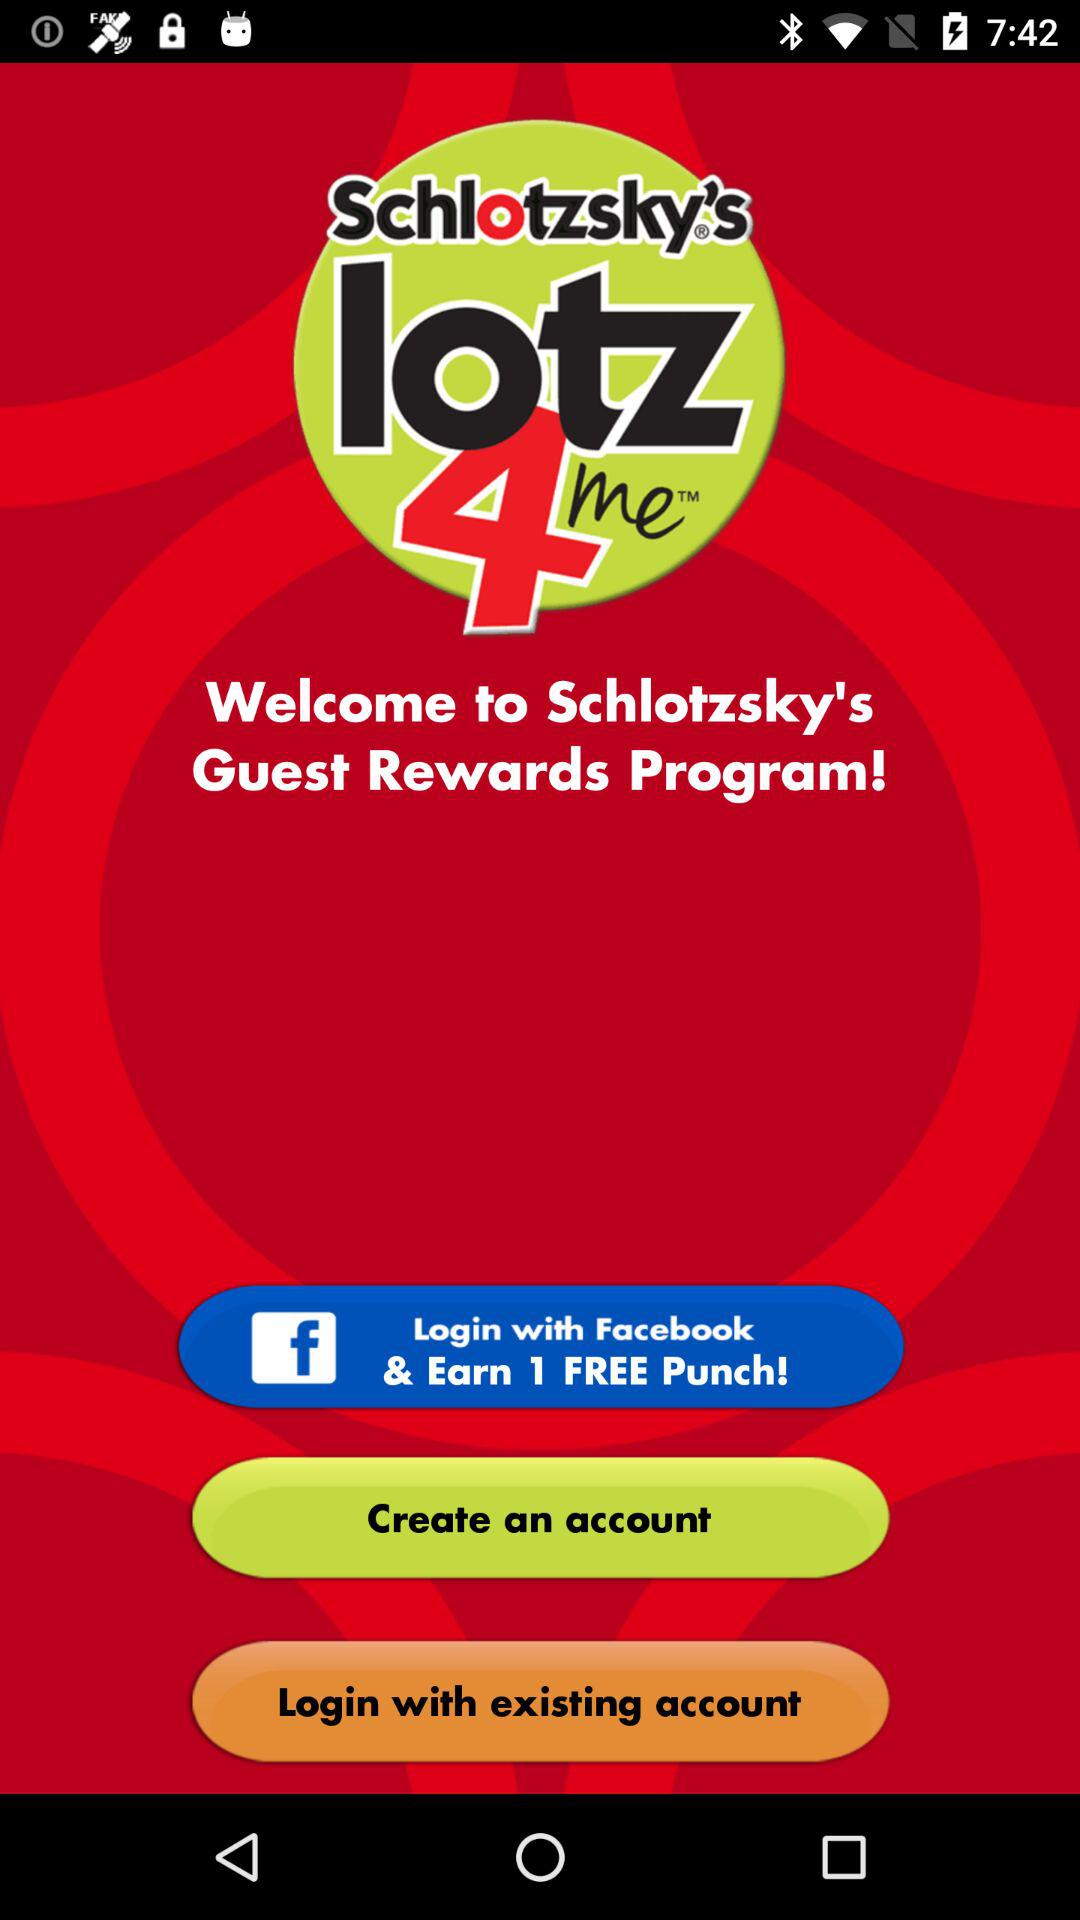What is the application name? The application name is "Schlotzsky's Rewards Program". 